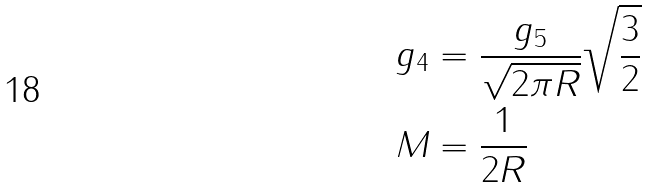Convert formula to latex. <formula><loc_0><loc_0><loc_500><loc_500>g _ { 4 } & = \frac { g _ { 5 } } { \sqrt { 2 \pi R } } \sqrt { \frac { 3 } { 2 } } \\ M & = \frac { 1 } { 2 R }</formula> 